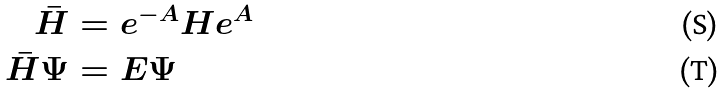Convert formula to latex. <formula><loc_0><loc_0><loc_500><loc_500>\bar { H } & = e ^ { - A } H e ^ { A } \\ \bar { H } \Psi & = E \Psi</formula> 